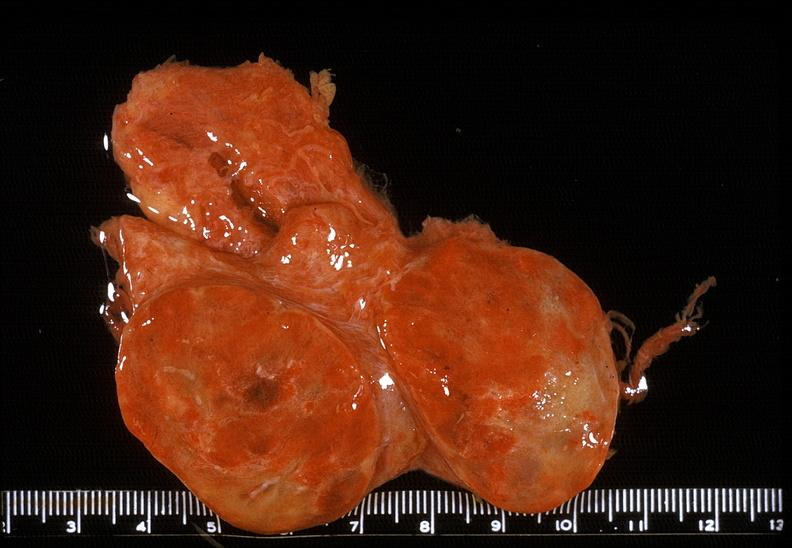does embryo-fetus show thyroid, follicular adenoma?
Answer the question using a single word or phrase. No 